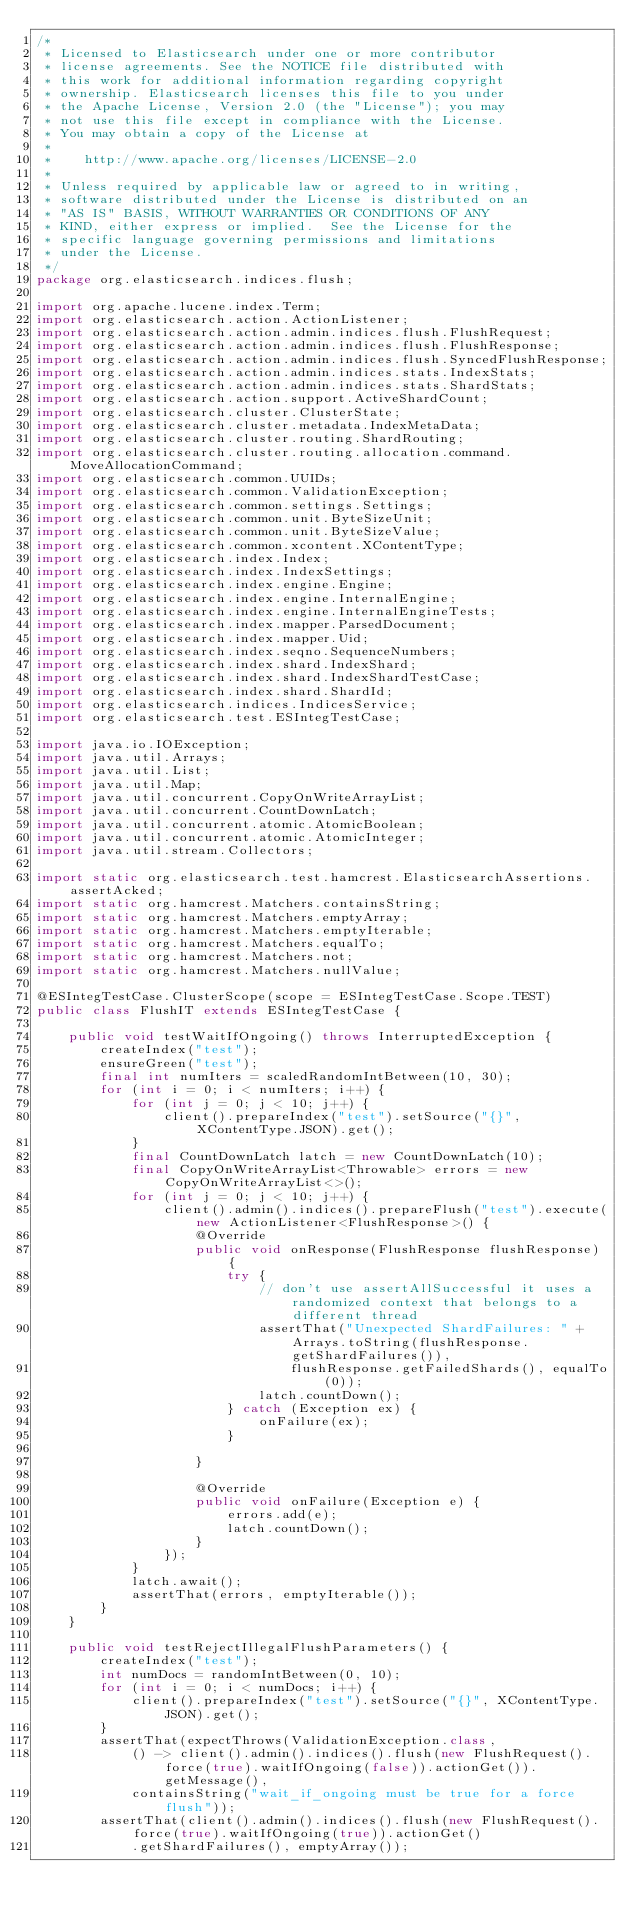Convert code to text. <code><loc_0><loc_0><loc_500><loc_500><_Java_>/*
 * Licensed to Elasticsearch under one or more contributor
 * license agreements. See the NOTICE file distributed with
 * this work for additional information regarding copyright
 * ownership. Elasticsearch licenses this file to you under
 * the Apache License, Version 2.0 (the "License"); you may
 * not use this file except in compliance with the License.
 * You may obtain a copy of the License at
 *
 *    http://www.apache.org/licenses/LICENSE-2.0
 *
 * Unless required by applicable law or agreed to in writing,
 * software distributed under the License is distributed on an
 * "AS IS" BASIS, WITHOUT WARRANTIES OR CONDITIONS OF ANY
 * KIND, either express or implied.  See the License for the
 * specific language governing permissions and limitations
 * under the License.
 */
package org.elasticsearch.indices.flush;

import org.apache.lucene.index.Term;
import org.elasticsearch.action.ActionListener;
import org.elasticsearch.action.admin.indices.flush.FlushRequest;
import org.elasticsearch.action.admin.indices.flush.FlushResponse;
import org.elasticsearch.action.admin.indices.flush.SyncedFlushResponse;
import org.elasticsearch.action.admin.indices.stats.IndexStats;
import org.elasticsearch.action.admin.indices.stats.ShardStats;
import org.elasticsearch.action.support.ActiveShardCount;
import org.elasticsearch.cluster.ClusterState;
import org.elasticsearch.cluster.metadata.IndexMetaData;
import org.elasticsearch.cluster.routing.ShardRouting;
import org.elasticsearch.cluster.routing.allocation.command.MoveAllocationCommand;
import org.elasticsearch.common.UUIDs;
import org.elasticsearch.common.ValidationException;
import org.elasticsearch.common.settings.Settings;
import org.elasticsearch.common.unit.ByteSizeUnit;
import org.elasticsearch.common.unit.ByteSizeValue;
import org.elasticsearch.common.xcontent.XContentType;
import org.elasticsearch.index.Index;
import org.elasticsearch.index.IndexSettings;
import org.elasticsearch.index.engine.Engine;
import org.elasticsearch.index.engine.InternalEngine;
import org.elasticsearch.index.engine.InternalEngineTests;
import org.elasticsearch.index.mapper.ParsedDocument;
import org.elasticsearch.index.mapper.Uid;
import org.elasticsearch.index.seqno.SequenceNumbers;
import org.elasticsearch.index.shard.IndexShard;
import org.elasticsearch.index.shard.IndexShardTestCase;
import org.elasticsearch.index.shard.ShardId;
import org.elasticsearch.indices.IndicesService;
import org.elasticsearch.test.ESIntegTestCase;

import java.io.IOException;
import java.util.Arrays;
import java.util.List;
import java.util.Map;
import java.util.concurrent.CopyOnWriteArrayList;
import java.util.concurrent.CountDownLatch;
import java.util.concurrent.atomic.AtomicBoolean;
import java.util.concurrent.atomic.AtomicInteger;
import java.util.stream.Collectors;

import static org.elasticsearch.test.hamcrest.ElasticsearchAssertions.assertAcked;
import static org.hamcrest.Matchers.containsString;
import static org.hamcrest.Matchers.emptyArray;
import static org.hamcrest.Matchers.emptyIterable;
import static org.hamcrest.Matchers.equalTo;
import static org.hamcrest.Matchers.not;
import static org.hamcrest.Matchers.nullValue;

@ESIntegTestCase.ClusterScope(scope = ESIntegTestCase.Scope.TEST)
public class FlushIT extends ESIntegTestCase {

    public void testWaitIfOngoing() throws InterruptedException {
        createIndex("test");
        ensureGreen("test");
        final int numIters = scaledRandomIntBetween(10, 30);
        for (int i = 0; i < numIters; i++) {
            for (int j = 0; j < 10; j++) {
                client().prepareIndex("test").setSource("{}", XContentType.JSON).get();
            }
            final CountDownLatch latch = new CountDownLatch(10);
            final CopyOnWriteArrayList<Throwable> errors = new CopyOnWriteArrayList<>();
            for (int j = 0; j < 10; j++) {
                client().admin().indices().prepareFlush("test").execute(new ActionListener<FlushResponse>() {
                    @Override
                    public void onResponse(FlushResponse flushResponse) {
                        try {
                            // don't use assertAllSuccessful it uses a randomized context that belongs to a different thread
                            assertThat("Unexpected ShardFailures: " + Arrays.toString(flushResponse.getShardFailures()),
                                flushResponse.getFailedShards(), equalTo(0));
                            latch.countDown();
                        } catch (Exception ex) {
                            onFailure(ex);
                        }

                    }

                    @Override
                    public void onFailure(Exception e) {
                        errors.add(e);
                        latch.countDown();
                    }
                });
            }
            latch.await();
            assertThat(errors, emptyIterable());
        }
    }

    public void testRejectIllegalFlushParameters() {
        createIndex("test");
        int numDocs = randomIntBetween(0, 10);
        for (int i = 0; i < numDocs; i++) {
            client().prepareIndex("test").setSource("{}", XContentType.JSON).get();
        }
        assertThat(expectThrows(ValidationException.class,
            () -> client().admin().indices().flush(new FlushRequest().force(true).waitIfOngoing(false)).actionGet()).getMessage(),
            containsString("wait_if_ongoing must be true for a force flush"));
        assertThat(client().admin().indices().flush(new FlushRequest().force(true).waitIfOngoing(true)).actionGet()
            .getShardFailures(), emptyArray());</code> 